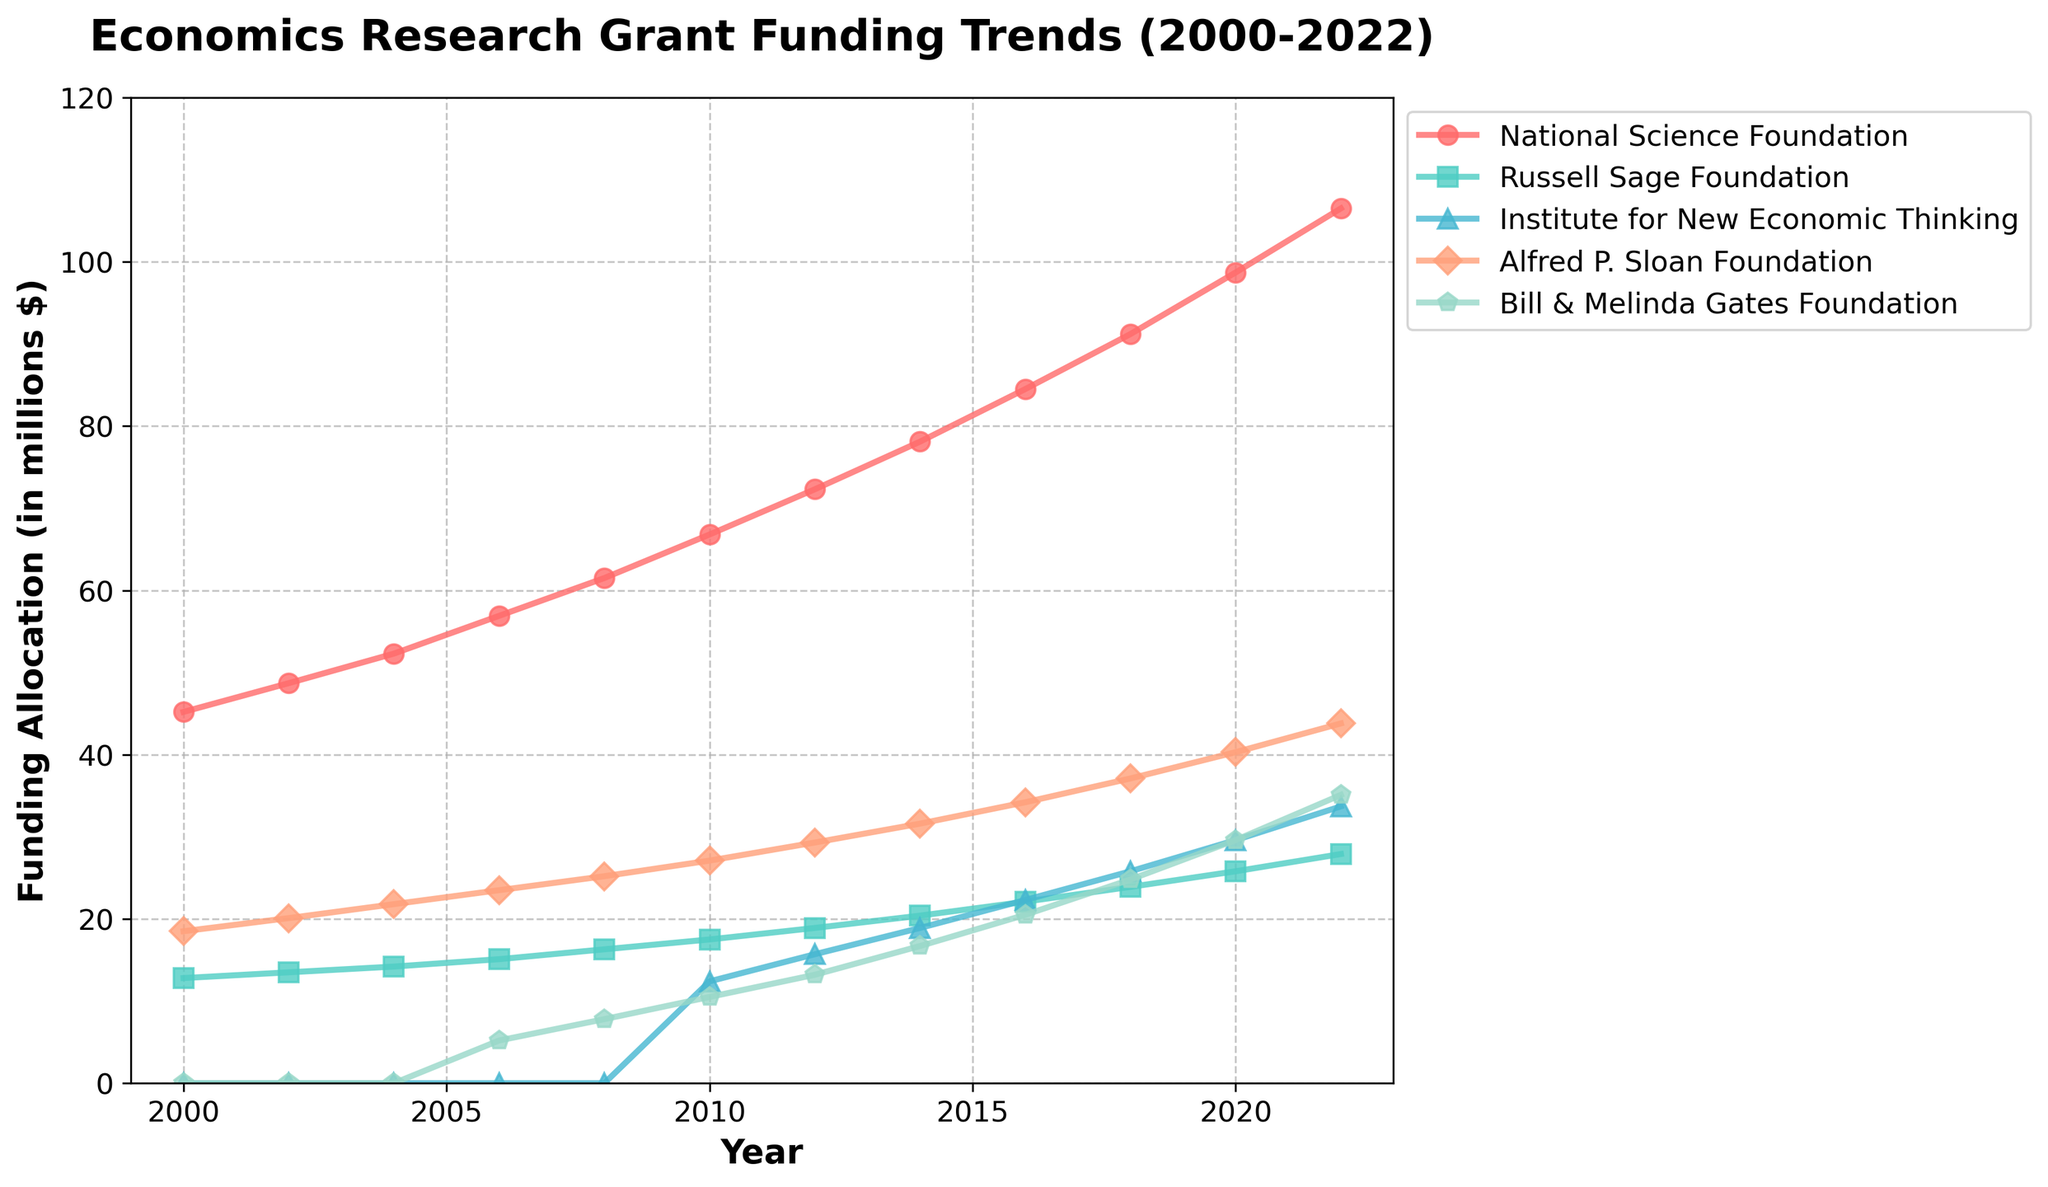What was the funding allocation for the Bill & Melinda Gates Foundation in 2006? To find the answer, refer to the line representing the Bill & Melinda Gates Foundation in 2006. The corresponding value is 5.2 million dollars.
Answer: 5.2 million dollars Which foundation had the highest funding allocation in 2022? Identify the highest point among all the lines in 2022. The National Science Foundation has the highest funding allocation at 106.5 million dollars.
Answer: National Science Foundation By how much did the funding allocation for the Alfred P. Sloan Foundation increase from 2000 to 2020? The Alfred P. Sloan Foundation had 18.5 million dollars in 2000 and 40.3 million dollars in 2020. The increase is 40.3 - 18.5 = 21.8 million dollars.
Answer: 21.8 million dollars Did any foundation show a decline in funding allocation in any year? Scan all lines for any downward trend between consecutive years. No foundation shows a decline; all exhibit upward trends throughout the years.
Answer: No Compare the funding allocation for the Institute for New Economic Thinking in 2010 and 2018. Which year had more funding, and by how much? In 2010, the Institute for New Economic Thinking had 12.4 million dollars, and in 2018, 25.8 million dollars. 2018 had more funding by 25.8 - 12.4 = 13.4 million dollars.
Answer: 2018 by 13.4 million dollars What was the average funding allocation for the Russell Sage Foundation over the entire period? The totals for each year are: 12.8, 13.5, 14.2, 15.1, 16.3, 17.5, 18.9, 20.4, 22.1, 23.9, 25.8, 27.9. The sum is 228.4 and there are 12 years. The average is 228.4 / 12 = 19.03.
Answer: 19.03 million dollars Between which two consecutive years did the National Science Foundation see the highest increase in funding allocation? Calculate the differences for each consecutive year: 3.5, 3.6, 4.6, 4.6, 4.6, 5.3, 5.5, 5.8, 6.4, 6.7, 7.5. The highest increase is from 2020 to 2022, which is 7.8 million dollars.
Answer: 2020 to 2022 What is the total combined funding allocation for all foundations in 2014? Sum the values for each foundation in 2014: 78.1 (NSF) + 20.4 (RSF) + 18.9 (INET) + 31.6 (APSF) + 16.7 (BMGF) = 165.7 million dollars.
Answer: 165.7 million dollars Which foundation had the smallest increase in funding allocation from 2010 to 2012? Calculate the increases for each foundation: NSF: 5.5, RSF: 1.4, INET: 3.3, APSF: 2.2, BMGF: 2.7. The smallest increase is for the Russell Sage Foundation at 1.4 million dollars.
Answer: Russell Sage Foundation 